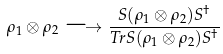<formula> <loc_0><loc_0><loc_500><loc_500>\rho _ { 1 } \otimes \rho _ { 2 } \longrightarrow \frac { S ( \rho _ { 1 } \otimes \rho _ { 2 } ) S ^ { \dagger } } { T r { S ( \rho _ { 1 } \otimes \rho _ { 2 } ) S ^ { \dagger } } }</formula> 